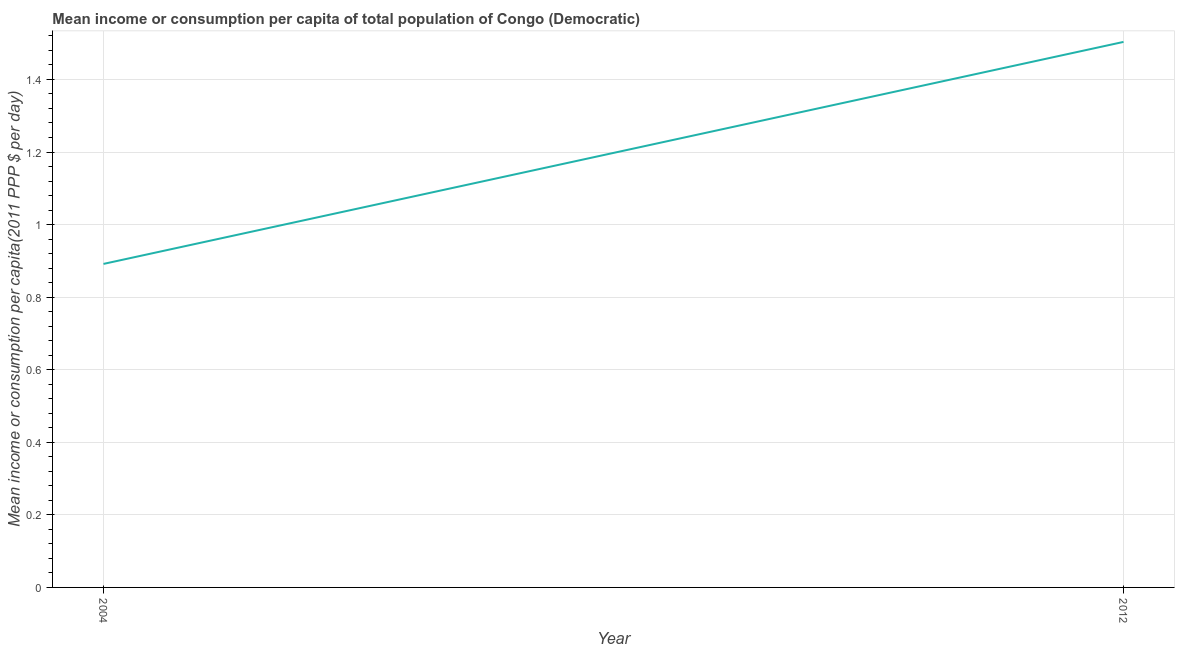What is the mean income or consumption in 2012?
Provide a succinct answer. 1.5. Across all years, what is the maximum mean income or consumption?
Offer a very short reply. 1.5. Across all years, what is the minimum mean income or consumption?
Ensure brevity in your answer.  0.89. What is the sum of the mean income or consumption?
Your answer should be very brief. 2.39. What is the difference between the mean income or consumption in 2004 and 2012?
Give a very brief answer. -0.61. What is the average mean income or consumption per year?
Make the answer very short. 1.2. What is the median mean income or consumption?
Provide a short and direct response. 1.2. In how many years, is the mean income or consumption greater than 0.7600000000000001 $?
Your answer should be compact. 2. Do a majority of the years between 2004 and 2012 (inclusive) have mean income or consumption greater than 0.88 $?
Provide a succinct answer. Yes. What is the ratio of the mean income or consumption in 2004 to that in 2012?
Provide a short and direct response. 0.59. Is the mean income or consumption in 2004 less than that in 2012?
Give a very brief answer. Yes. How many years are there in the graph?
Give a very brief answer. 2. What is the difference between two consecutive major ticks on the Y-axis?
Make the answer very short. 0.2. Are the values on the major ticks of Y-axis written in scientific E-notation?
Your answer should be very brief. No. Does the graph contain grids?
Offer a terse response. Yes. What is the title of the graph?
Offer a terse response. Mean income or consumption per capita of total population of Congo (Democratic). What is the label or title of the Y-axis?
Provide a succinct answer. Mean income or consumption per capita(2011 PPP $ per day). What is the Mean income or consumption per capita(2011 PPP $ per day) in 2004?
Your response must be concise. 0.89. What is the Mean income or consumption per capita(2011 PPP $ per day) of 2012?
Make the answer very short. 1.5. What is the difference between the Mean income or consumption per capita(2011 PPP $ per day) in 2004 and 2012?
Your response must be concise. -0.61. What is the ratio of the Mean income or consumption per capita(2011 PPP $ per day) in 2004 to that in 2012?
Offer a terse response. 0.59. 